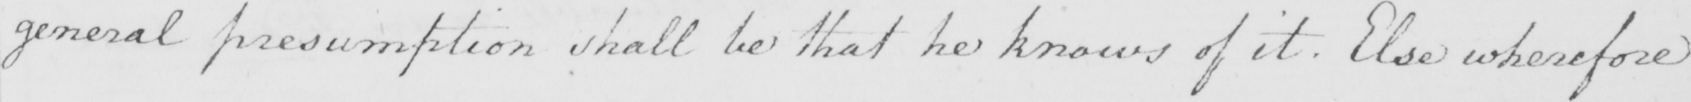Please provide the text content of this handwritten line. general presumption shall be that he knows of it . Else wherefore 